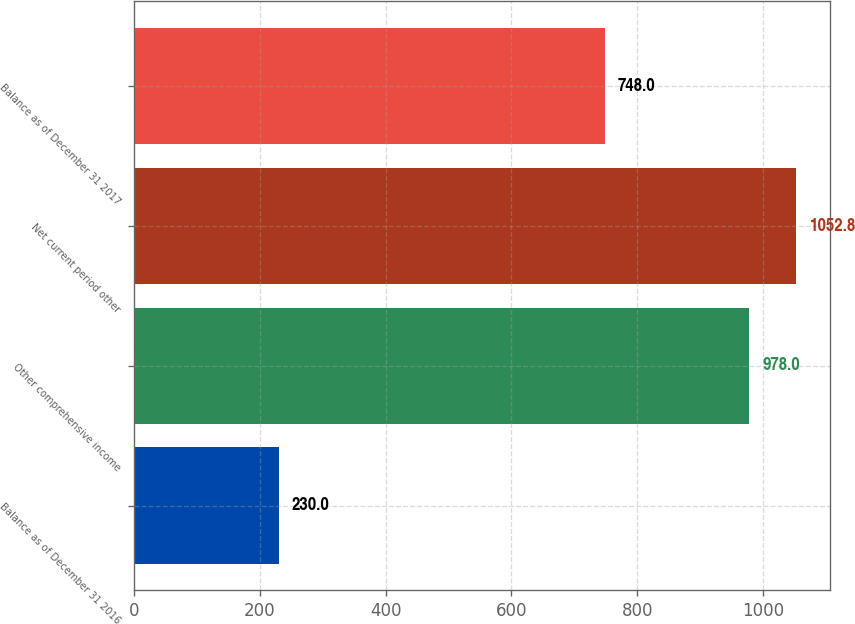Convert chart to OTSL. <chart><loc_0><loc_0><loc_500><loc_500><bar_chart><fcel>Balance as of December 31 2016<fcel>Other comprehensive income<fcel>Net current period other<fcel>Balance as of December 31 2017<nl><fcel>230<fcel>978<fcel>1052.8<fcel>748<nl></chart> 